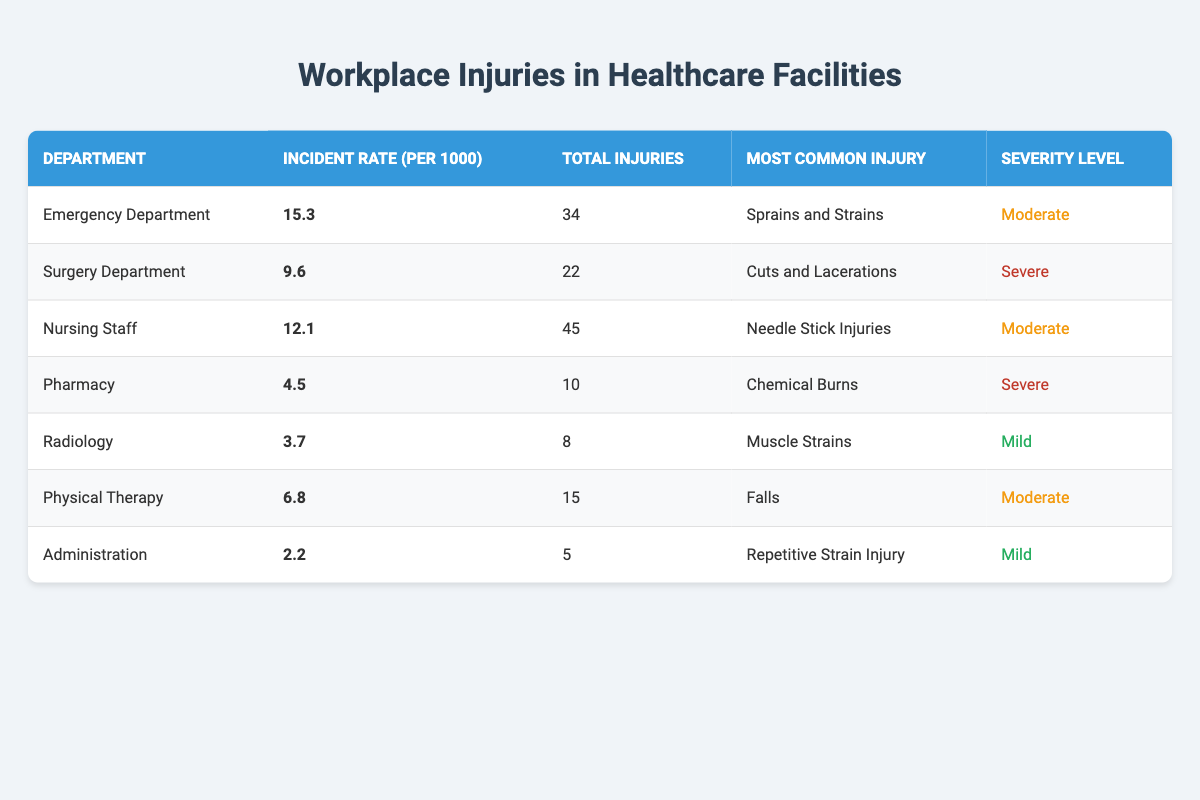What is the incident rate for the Emergency Department? The table lists the incident rate for the Emergency Department as 15.3 per 1000.
Answer: 15.3 Which department has the highest total injuries? By looking at the total injuries column, the Nursing Staff department has the highest total injuries with 45 injuries.
Answer: Nursing Staff What is the most common injury reported in the Surgery Department? The table indicates that the most common injury reported in the Surgery Department is Cuts and Lacerations.
Answer: Cuts and Lacerations Is the severity level of injuries higher in the Emergency Department compared to the Pharmacy? The Emergency Department has a moderate severity level while the Pharmacy has a severe severity level. Thus, injuries in the Pharmacy are of higher severity compared to the Emergency Department.
Answer: Yes What is the average incident rate across all departments? To find the average incident rate, add all incident rates together: 15.3 + 9.6 + 12.1 + 4.5 + 3.7 + 6.8 + 2.2 = 54.2. There are 7 departments, so divide by 7: 54.2 / 7 = 7.743.
Answer: 7.743 Which department has the lowest incident rate, and what is that rate? The Pharmacy has the lowest incident rate listed in the table at 4.5 per 1000.
Answer: Pharmacy, 4.5 How many total injuries were reported in departments with moderate severity levels? The departments with moderate severity levels are the Emergency Department, Nursing Staff, and Physical Therapy. The total injuries are: 34 (Emergency Department) + 45 (Nursing Staff) + 15 (Physical Therapy) = 94.
Answer: 94 What proportion of total injuries in the Nursing Staff is classified as severe? The Nursing Staff has 45 total injuries, and none of them is classified as severe (only moderate injuries). Therefore, the proportion of severe injuries is 0 out of 45, which is 0%.
Answer: 0% Are there any departments with mild severity injuries that report total injuries more than 10? The only department with mild severity injuries is Administration with 5 injuries and Radiology with 8 injuries, both of which report fewer than 10 injuries. Therefore, there are no departments with mild severity injuries that report more than 10 total injuries.
Answer: No 